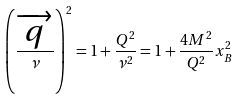Convert formula to latex. <formula><loc_0><loc_0><loc_500><loc_500>\left ( \frac { \overrightarrow { q } } \nu \right ) ^ { 2 } = 1 + \frac { Q ^ { 2 } } { \nu ^ { 2 } } = 1 + \frac { 4 M ^ { 2 } } { Q ^ { 2 } } x _ { B } ^ { 2 }</formula> 